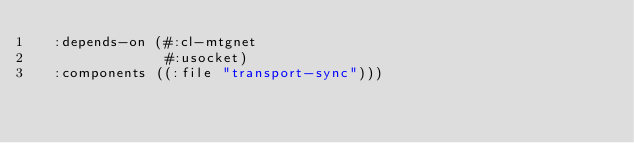<code> <loc_0><loc_0><loc_500><loc_500><_Lisp_>  :depends-on (#:cl-mtgnet
               #:usocket)
  :components ((:file "transport-sync")))
</code> 